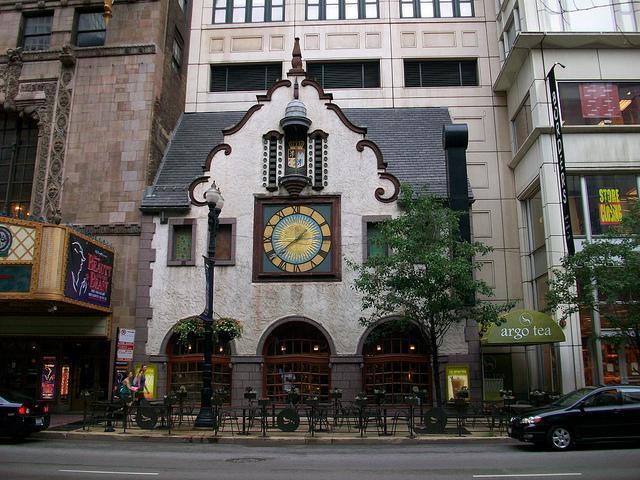How many dogs can be seen?
Give a very brief answer. 0. 